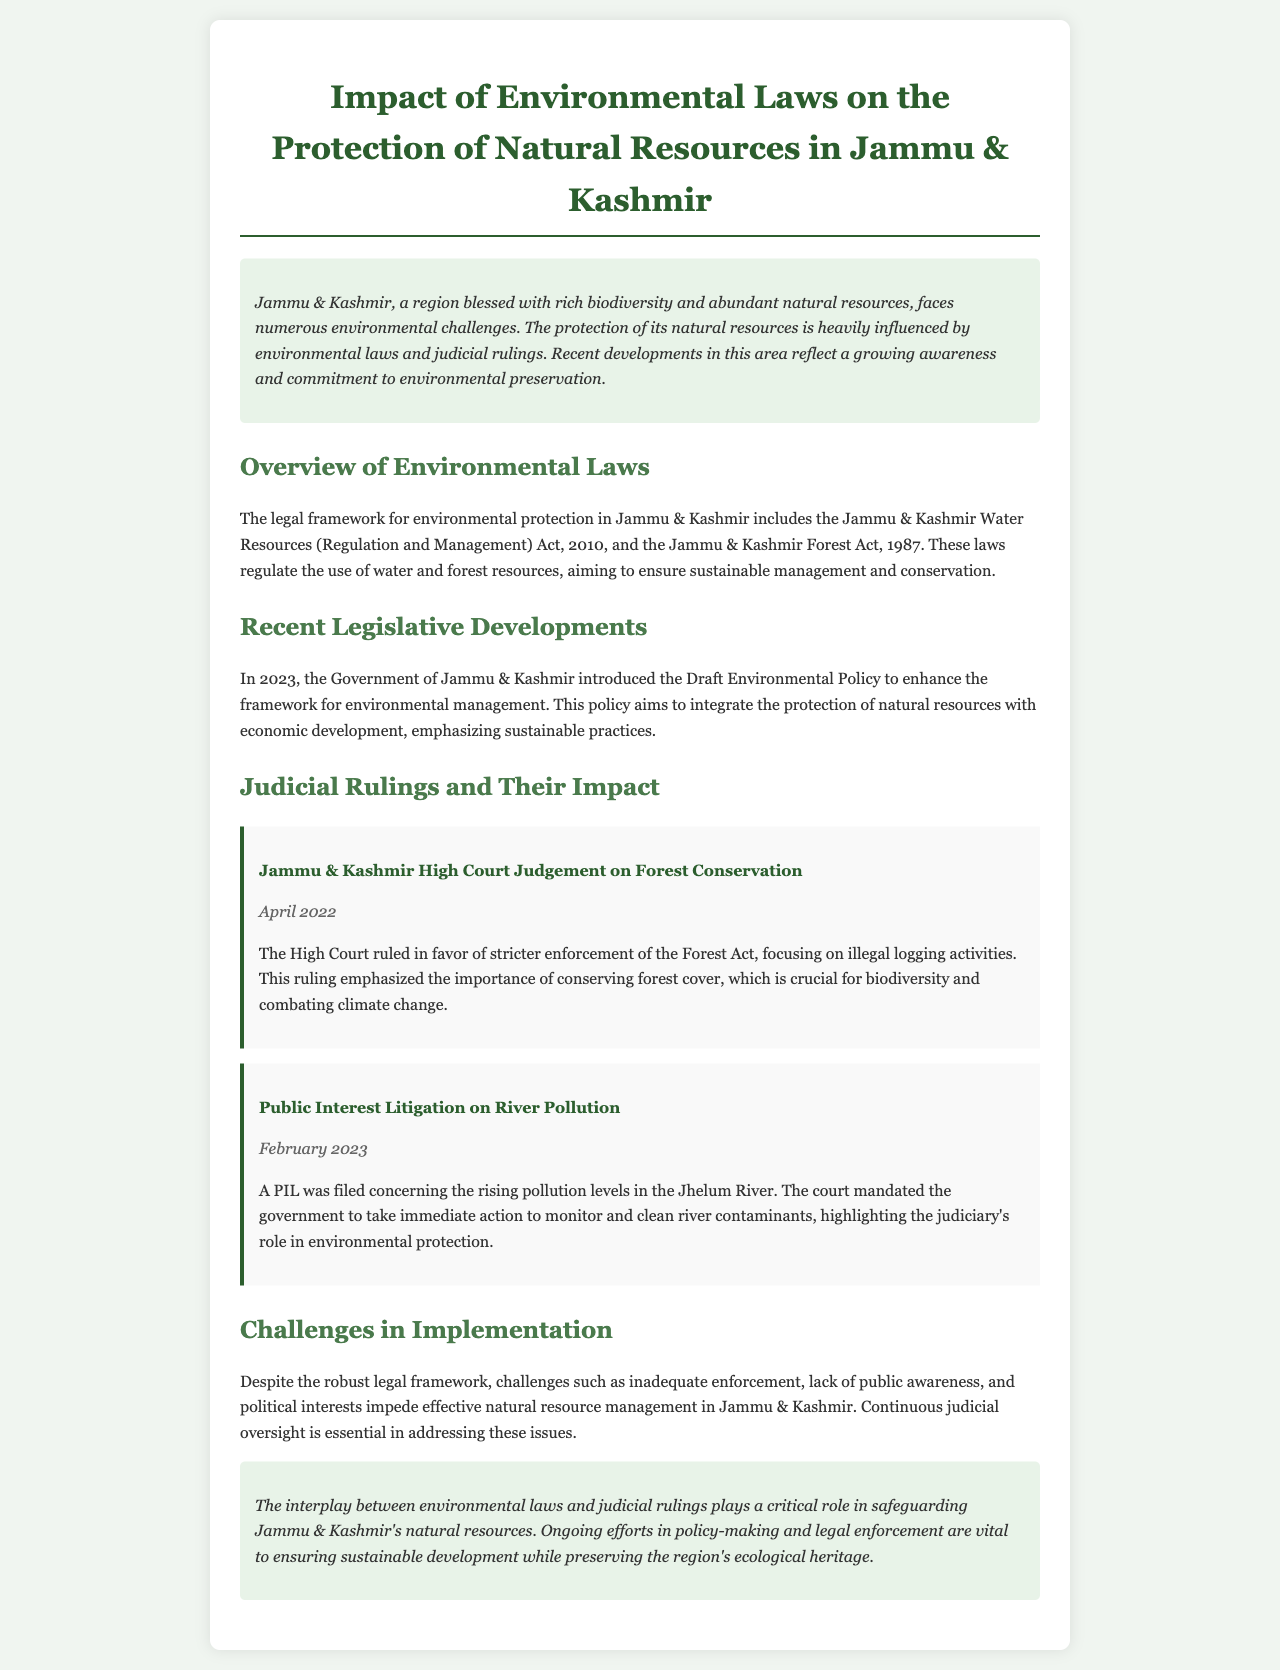what are the main environmental laws in Jammu & Kashmir? The document identifies two main laws: the Jammu & Kashmir Water Resources (Regulation and Management) Act, 2010, and the Jammu & Kashmir Forest Act, 1987.
Answer: Jammu & Kashmir Water Resources (Regulation and Management) Act, 2010; Jammu & Kashmir Forest Act, 1987 when was the Draft Environmental Policy introduced? The Draft Environmental Policy was introduced in 2023 to enhance the framework for environmental management.
Answer: 2023 what was the outcome of the High Court ruling in April 2022? The High Court ruled in favor of stricter enforcement of the Forest Act, emphasizing forest conservation and illegal logging.
Answer: Stricter enforcement of the Forest Act what issue was highlighted in the Public Interest Litigation filed in February 2023? The PIL addressed rising pollution levels in the Jhelum River and mandated government action for monitoring and cleaning.
Answer: Pollution levels in the Jhelum River what are some challenges in implementing environmental laws in Jammu & Kashmir? The document lists challenges such as inadequate enforcement, lack of public awareness, and political interests that impede effective management.
Answer: Inadequate enforcement, lack of public awareness, political interests what is the significance of judicial rulings in environmental protection according to the report? The report emphasizes that continuous judicial oversight is essential for addressing challenges in natural resource management.
Answer: Continuous judicial oversight is essential 